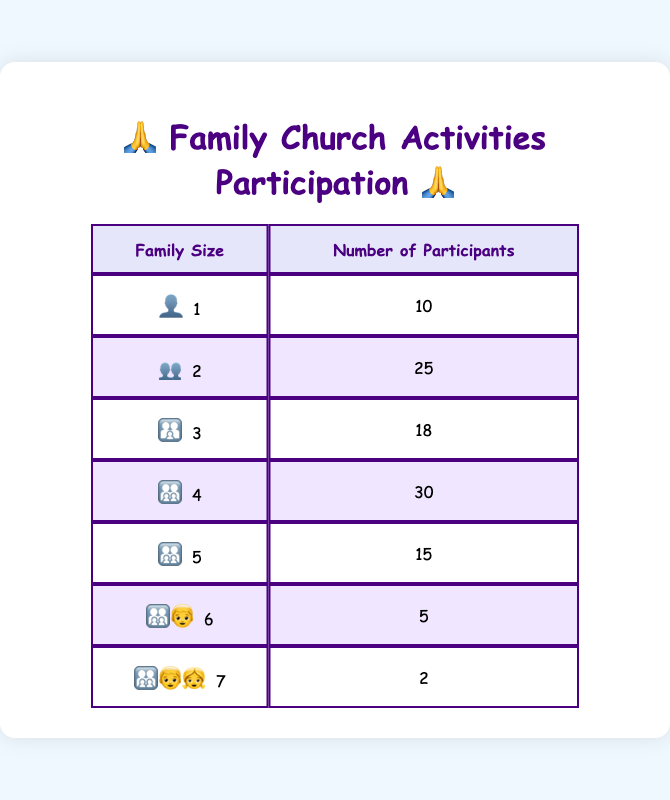What is the number of participants from families of size 2? In the table, when looking for family size 2, we find that the number of participants is listed directly as 25.
Answer: 25 How many participants are there from families of size 4? The table shows that for family size 4, the number of participants is 30.
Answer: 30 Which family size has the least number of participants? By checking the participant counts for each family size, family size 7 has the least number of participants, with only 2 listed.
Answer: 7 What is the total number of participants across all family sizes? To find the total, we sum the participants for all family sizes: 10 + 25 + 18 + 30 + 15 + 5 + 2 = 105.
Answer: 105 What is the average number of participants per family size? There are 7 family sizes, and the total participants are 105. To find the average, we divide total participants by family sizes: 105/7 = 15. So, average participants = 15.
Answer: 15 Is the number of participants in families of size 6 greater than those in families of size 5? The table shows 5 participants for families of size 6 and 15 for families of size 5. Since 5 is not greater than 15, the answer is no.
Answer: No How many more participants are there in families of size 4 compared to size 3? Families of size 4 have 30 participants and size 3 have 18. The difference is 30 - 18 = 12. Thus, there are 12 more participants in size 4.
Answer: 12 If we combine the participants from families of size 1 and size 2, how many participants would there be in total? For family size 1, there are 10 participants, and for size 2, there are 25. Adding these gives us 10 + 25 = 35.
Answer: 35 What proportion of participants come from families of size 5 or more? First, we sum the participants from families of size 5, 6, and 7: 15 + 5 + 2 = 22. With a total of 105 participants, the proportion is 22/105, which simplifies to approximately 0.209 or 20.9%.
Answer: 20.9% 